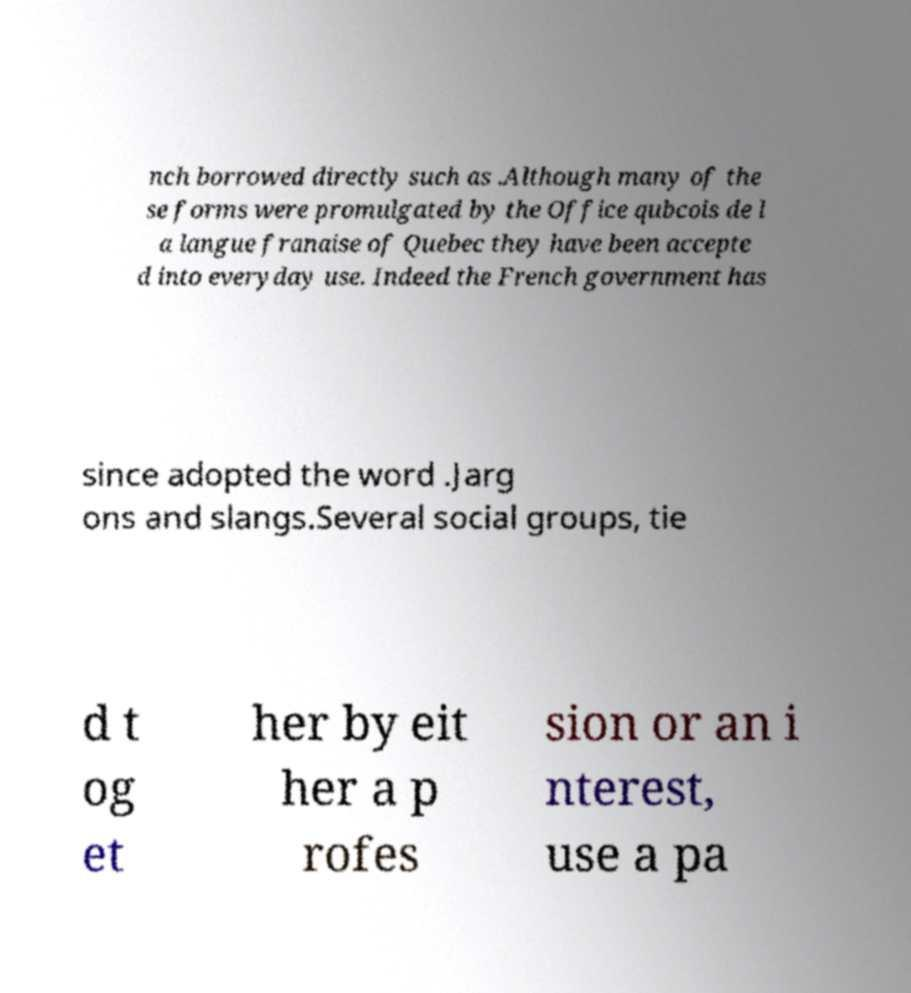Could you assist in decoding the text presented in this image and type it out clearly? nch borrowed directly such as .Although many of the se forms were promulgated by the Office qubcois de l a langue franaise of Quebec they have been accepte d into everyday use. Indeed the French government has since adopted the word .Jarg ons and slangs.Several social groups, tie d t og et her by eit her a p rofes sion or an i nterest, use a pa 